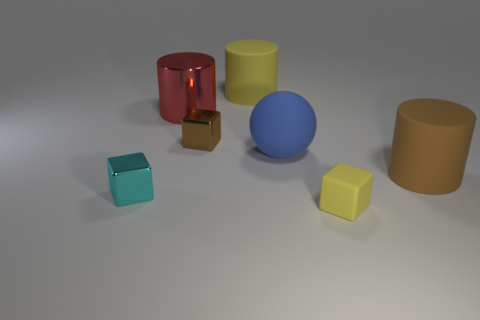How many matte cylinders have the same color as the small matte thing?
Make the answer very short. 1. What is the material of the big object that is the same color as the rubber block?
Offer a terse response. Rubber. Do the small rubber block and the large rubber object behind the metal cylinder have the same color?
Provide a short and direct response. Yes. There is a metallic block to the right of the tiny cyan object; is its size the same as the rubber thing that is in front of the small cyan cube?
Offer a terse response. Yes. How many cubes are brown rubber things or blue rubber things?
Make the answer very short. 0. Is there a cyan object?
Keep it short and to the point. Yes. Is there any other thing that has the same shape as the blue matte object?
Your answer should be very brief. No. How many objects are either brown things that are in front of the rubber ball or big green cylinders?
Keep it short and to the point. 1. What number of tiny brown things are on the left side of the yellow thing that is behind the metal block left of the large red object?
Your answer should be compact. 1. The yellow rubber thing that is behind the big rubber cylinder that is on the right side of the yellow thing behind the cyan metallic object is what shape?
Offer a very short reply. Cylinder. 